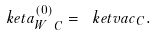<formula> <loc_0><loc_0><loc_500><loc_500>\ k e t { a _ { W } ^ { ( 0 ) } } _ { C } = \ k e t { v a c } _ { C } .</formula> 